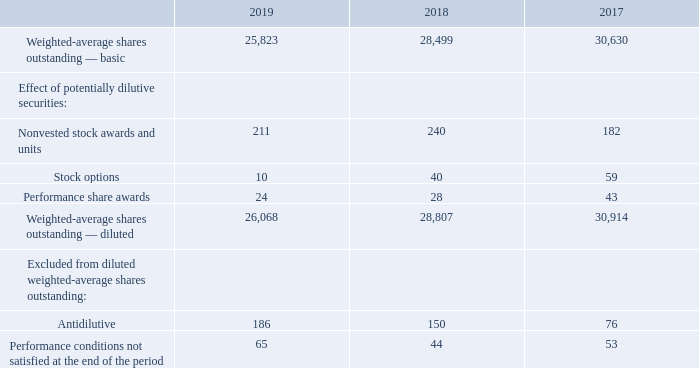15. AVERAGE SHARES OUTSTANDING
Our basic earnings per share calculation is computed based on the weighted-average number of common shares outstanding. Our diluted earnings per share calculation is computed based on the weighted-average number of common shares outstanding adjusted by the number of additional shares that would have been outstanding had the potentially dilutive common shares been issued. Potentially dilutive common shares include nonvested stock awards and units, stock options, and non-management director stock equivalents. Performance share awards are included in the average diluted shares outstanding each period if the performance criteria have been met at the end of the respective periods.
The following table reconciles basic weighted-average shares outstanding to diluted weighted-average shares outstanding in each fiscal year (in thousands):
How is the basic earnings per share calculation computed? Based on the weighted-average number of common shares outstanding. What is the value of dilute weighted-average shares outstanding in 2019? 
Answer scale should be: thousand. 26,068. When are performance share awards included in the average diluted shares outstanding each period? If the performance criteria have been met at the end of the respective periods. What is the average number of basic weighted-average shares outstanding from 2017-2019?
Answer scale should be: thousand. (25,823+28,499+30,630)/3
Answer: 28317.33. What is the difference in nonvested stock awards and units between 2018 and 2019?
Answer scale should be: thousand. 240-211
Answer: 29. What is the percentage constitution of performance share awards among the total diluted weighted-average shares outstanding in 2018?
Answer scale should be: percent. 28/28,807
Answer: 0.1. 